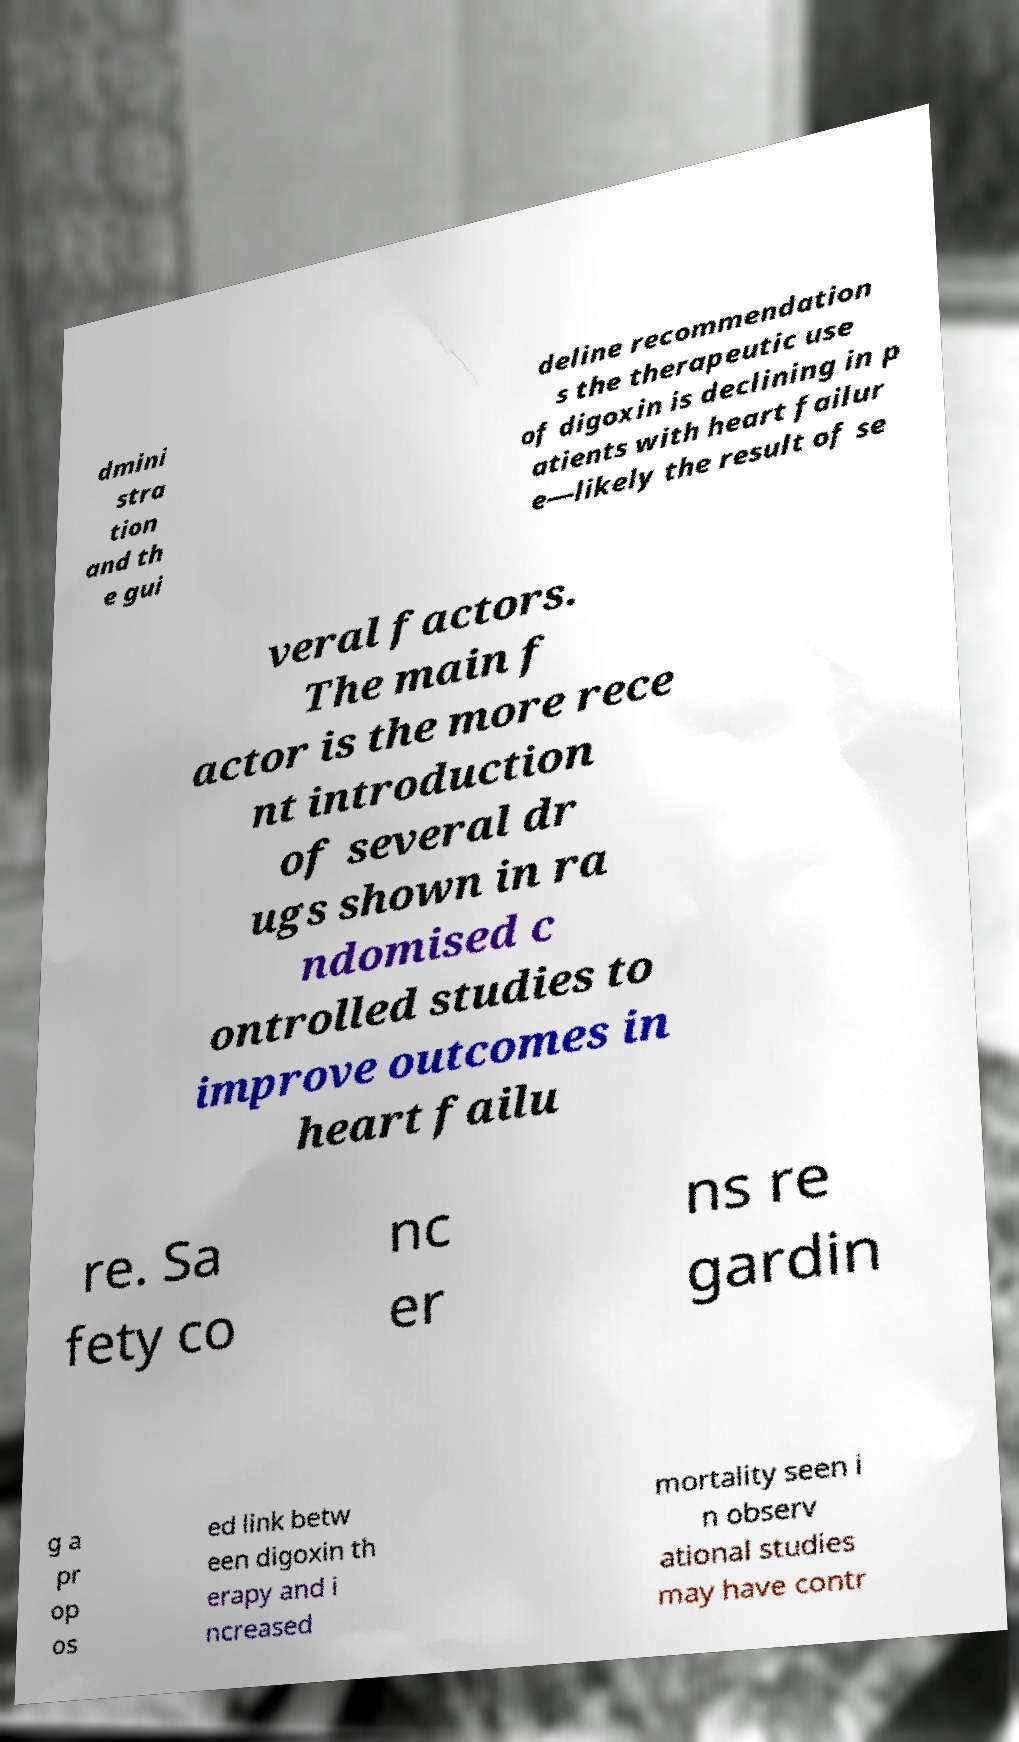There's text embedded in this image that I need extracted. Can you transcribe it verbatim? dmini stra tion and th e gui deline recommendation s the therapeutic use of digoxin is declining in p atients with heart failur e—likely the result of se veral factors. The main f actor is the more rece nt introduction of several dr ugs shown in ra ndomised c ontrolled studies to improve outcomes in heart failu re. Sa fety co nc er ns re gardin g a pr op os ed link betw een digoxin th erapy and i ncreased mortality seen i n observ ational studies may have contr 